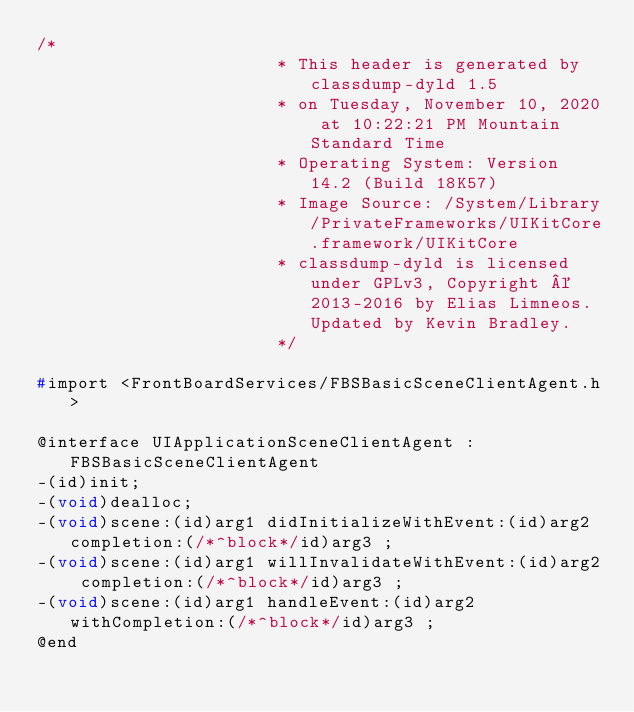Convert code to text. <code><loc_0><loc_0><loc_500><loc_500><_C_>/*
                       * This header is generated by classdump-dyld 1.5
                       * on Tuesday, November 10, 2020 at 10:22:21 PM Mountain Standard Time
                       * Operating System: Version 14.2 (Build 18K57)
                       * Image Source: /System/Library/PrivateFrameworks/UIKitCore.framework/UIKitCore
                       * classdump-dyld is licensed under GPLv3, Copyright © 2013-2016 by Elias Limneos. Updated by Kevin Bradley.
                       */

#import <FrontBoardServices/FBSBasicSceneClientAgent.h>

@interface UIApplicationSceneClientAgent : FBSBasicSceneClientAgent
-(id)init;
-(void)dealloc;
-(void)scene:(id)arg1 didInitializeWithEvent:(id)arg2 completion:(/*^block*/id)arg3 ;
-(void)scene:(id)arg1 willInvalidateWithEvent:(id)arg2 completion:(/*^block*/id)arg3 ;
-(void)scene:(id)arg1 handleEvent:(id)arg2 withCompletion:(/*^block*/id)arg3 ;
@end

</code> 